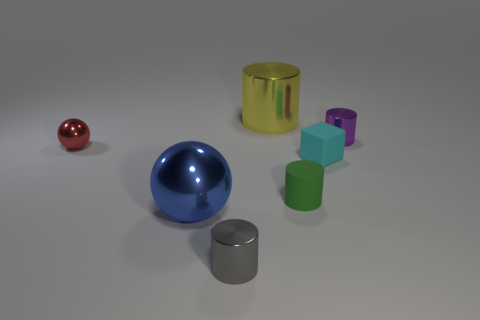Subtract all purple metallic cylinders. How many cylinders are left? 3 Subtract all gray cylinders. How many cylinders are left? 3 Subtract 2 cylinders. How many cylinders are left? 2 Add 2 tiny metallic objects. How many objects exist? 9 Subtract all cylinders. How many objects are left? 3 Subtract all brown cylinders. Subtract all cyan balls. How many cylinders are left? 4 Subtract all large cyan matte balls. Subtract all small red metallic things. How many objects are left? 6 Add 3 metallic cylinders. How many metallic cylinders are left? 6 Add 1 small gray rubber spheres. How many small gray rubber spheres exist? 1 Subtract 0 green balls. How many objects are left? 7 